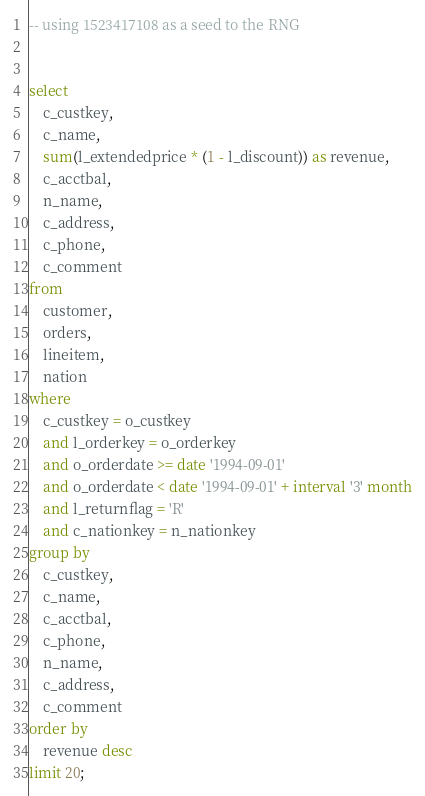<code> <loc_0><loc_0><loc_500><loc_500><_SQL_>-- using 1523417108 as a seed to the RNG


select
	c_custkey,
	c_name,
	sum(l_extendedprice * (1 - l_discount)) as revenue,
	c_acctbal,
	n_name,
	c_address,
	c_phone,
	c_comment
from
	customer,
	orders,
	lineitem,
	nation
where
	c_custkey = o_custkey
	and l_orderkey = o_orderkey
	and o_orderdate >= date '1994-09-01'
	and o_orderdate < date '1994-09-01' + interval '3' month
	and l_returnflag = 'R'
	and c_nationkey = n_nationkey
group by
	c_custkey,
	c_name,
	c_acctbal,
	c_phone,
	n_name,
	c_address,
	c_comment
order by
	revenue desc
limit 20;
</code> 